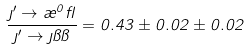<formula> <loc_0><loc_0><loc_500><loc_500>\frac { \eta ^ { \prime } \rightarrow \rho ^ { 0 } \gamma } { \eta ^ { \prime } \rightarrow \eta \pi \pi } = 0 . 4 3 \pm 0 . 0 2 \pm 0 . 0 2</formula> 